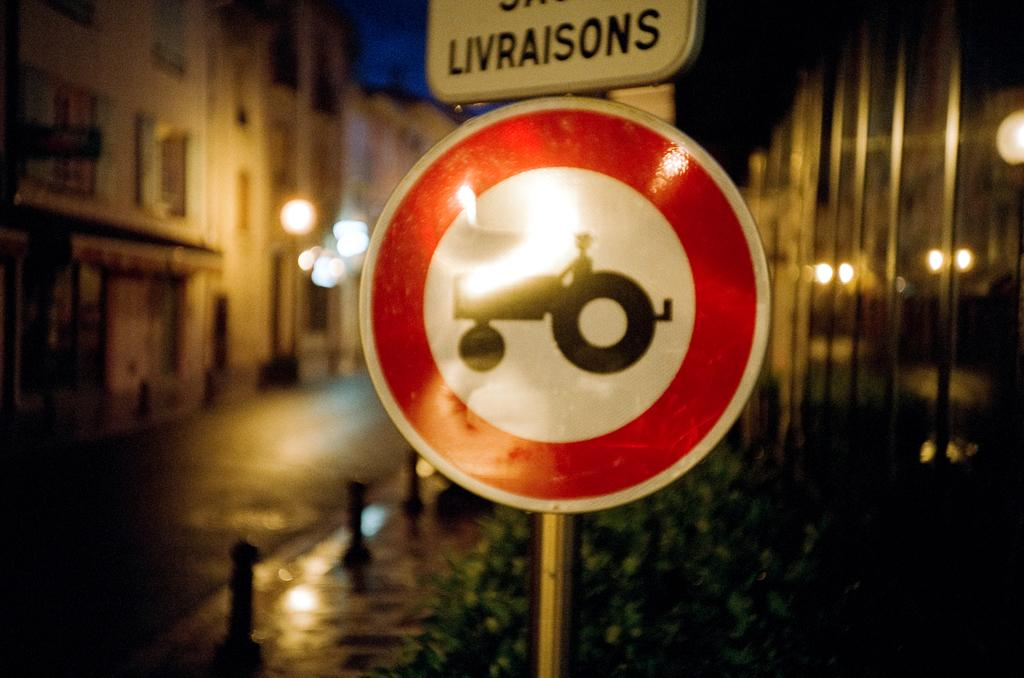<image>
Describe the image concisely. A sign that says, 'Livraisons', is above a sign with the image of a tractor on it. 